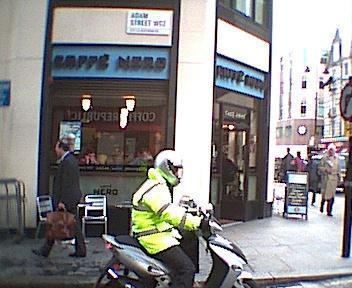How many tables are outside the business?
Give a very brief answer. 1. How many helmets are being worn?
Give a very brief answer. 1. How many motorcycles are there?
Give a very brief answer. 1. How many people can be seen?
Give a very brief answer. 2. How many people are wearing a tie in the picture?
Give a very brief answer. 0. 